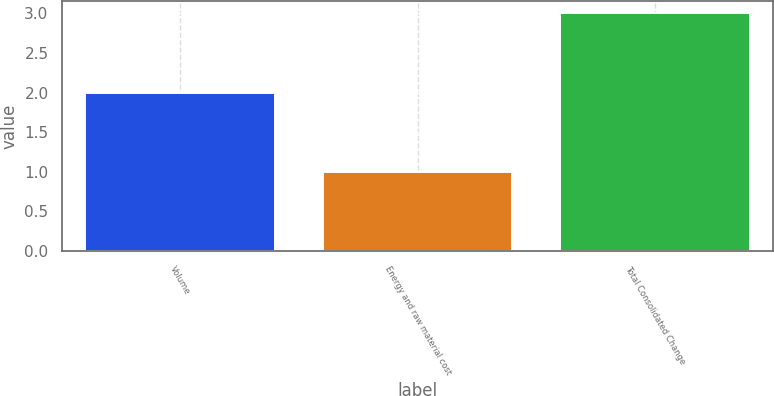Convert chart to OTSL. <chart><loc_0><loc_0><loc_500><loc_500><bar_chart><fcel>Volume<fcel>Energy and raw material cost<fcel>Total Consolidated Change<nl><fcel>2<fcel>1<fcel>3<nl></chart> 